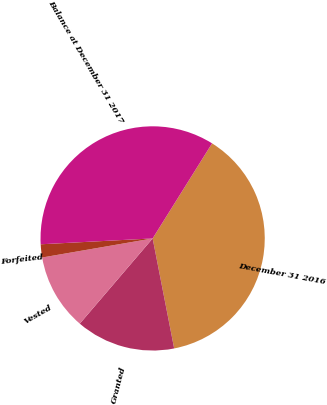<chart> <loc_0><loc_0><loc_500><loc_500><pie_chart><fcel>December 31 2016<fcel>Granted<fcel>Vested<fcel>Forfeited<fcel>Balance at December 31 2017<nl><fcel>38.03%<fcel>14.33%<fcel>11.02%<fcel>1.89%<fcel>34.72%<nl></chart> 